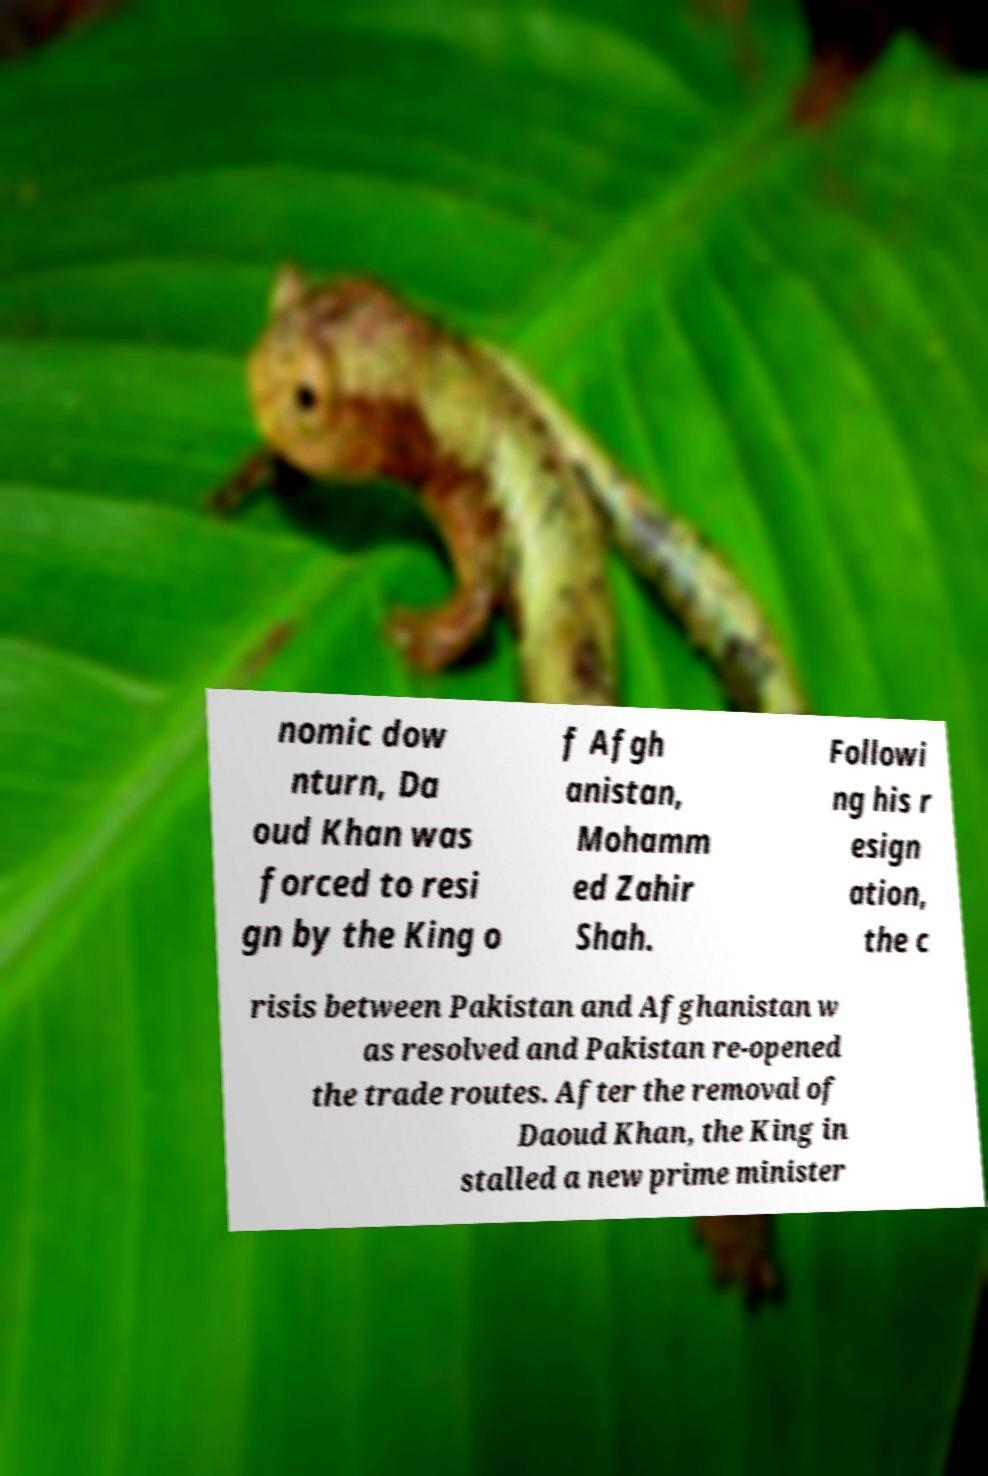I need the written content from this picture converted into text. Can you do that? nomic dow nturn, Da oud Khan was forced to resi gn by the King o f Afgh anistan, Mohamm ed Zahir Shah. Followi ng his r esign ation, the c risis between Pakistan and Afghanistan w as resolved and Pakistan re-opened the trade routes. After the removal of Daoud Khan, the King in stalled a new prime minister 